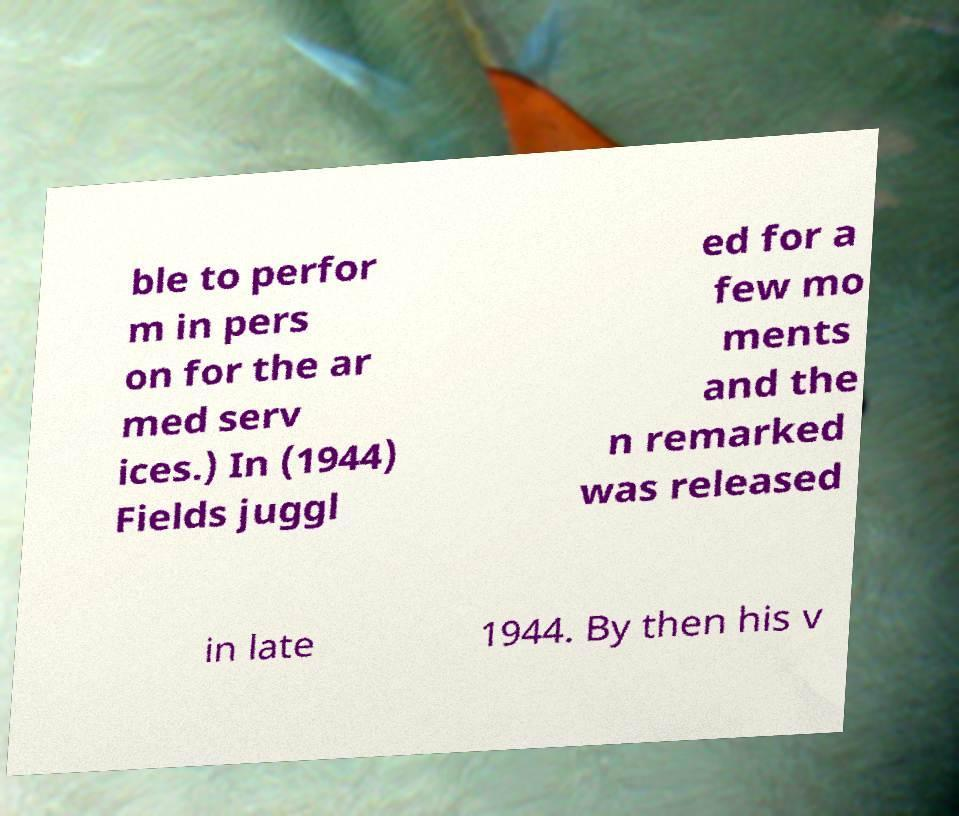What messages or text are displayed in this image? I need them in a readable, typed format. ble to perfor m in pers on for the ar med serv ices.) In (1944) Fields juggl ed for a few mo ments and the n remarked was released in late 1944. By then his v 